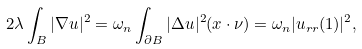<formula> <loc_0><loc_0><loc_500><loc_500>2 \lambda \int _ { B } | \nabla u | ^ { 2 } = \omega _ { n } \int _ { \partial B } | \Delta u | ^ { 2 } ( x \cdot \nu ) = \omega _ { n } | u _ { r r } ( 1 ) | ^ { 2 } ,</formula> 